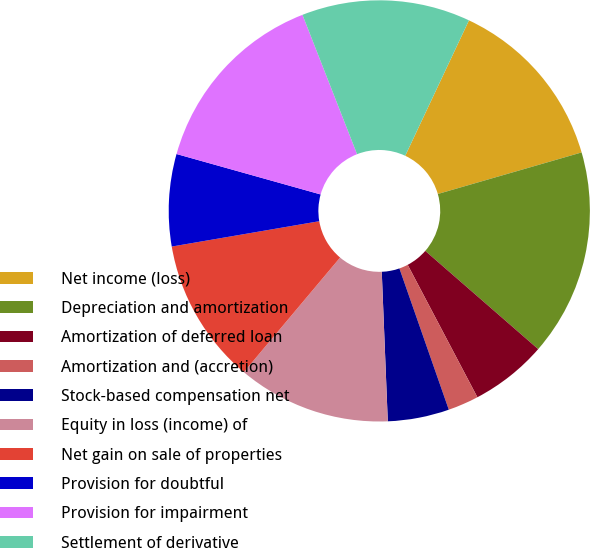Convert chart to OTSL. <chart><loc_0><loc_0><loc_500><loc_500><pie_chart><fcel>Net income (loss)<fcel>Depreciation and amortization<fcel>Amortization of deferred loan<fcel>Amortization and (accretion)<fcel>Stock-based compensation net<fcel>Equity in loss (income) of<fcel>Net gain on sale of properties<fcel>Provision for doubtful<fcel>Provision for impairment<fcel>Settlement of derivative<nl><fcel>13.52%<fcel>15.87%<fcel>5.89%<fcel>2.36%<fcel>4.71%<fcel>11.76%<fcel>11.17%<fcel>7.06%<fcel>14.7%<fcel>12.94%<nl></chart> 